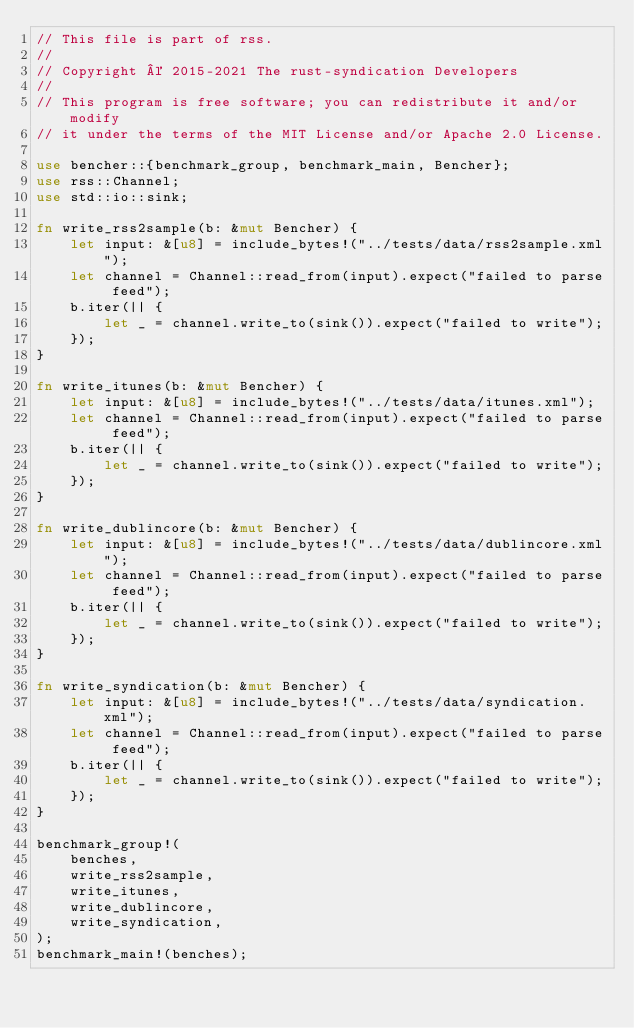<code> <loc_0><loc_0><loc_500><loc_500><_Rust_>// This file is part of rss.
//
// Copyright © 2015-2021 The rust-syndication Developers
//
// This program is free software; you can redistribute it and/or modify
// it under the terms of the MIT License and/or Apache 2.0 License.

use bencher::{benchmark_group, benchmark_main, Bencher};
use rss::Channel;
use std::io::sink;

fn write_rss2sample(b: &mut Bencher) {
    let input: &[u8] = include_bytes!("../tests/data/rss2sample.xml");
    let channel = Channel::read_from(input).expect("failed to parse feed");
    b.iter(|| {
        let _ = channel.write_to(sink()).expect("failed to write");
    });
}

fn write_itunes(b: &mut Bencher) {
    let input: &[u8] = include_bytes!("../tests/data/itunes.xml");
    let channel = Channel::read_from(input).expect("failed to parse feed");
    b.iter(|| {
        let _ = channel.write_to(sink()).expect("failed to write");
    });
}

fn write_dublincore(b: &mut Bencher) {
    let input: &[u8] = include_bytes!("../tests/data/dublincore.xml");
    let channel = Channel::read_from(input).expect("failed to parse feed");
    b.iter(|| {
        let _ = channel.write_to(sink()).expect("failed to write");
    });
}

fn write_syndication(b: &mut Bencher) {
    let input: &[u8] = include_bytes!("../tests/data/syndication.xml");
    let channel = Channel::read_from(input).expect("failed to parse feed");
    b.iter(|| {
        let _ = channel.write_to(sink()).expect("failed to write");
    });
}

benchmark_group!(
    benches,
    write_rss2sample,
    write_itunes,
    write_dublincore,
    write_syndication,
);
benchmark_main!(benches);
</code> 